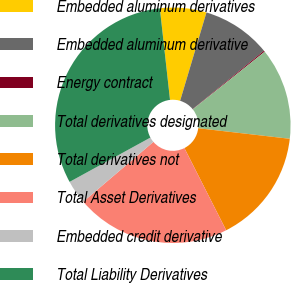Convert chart to OTSL. <chart><loc_0><loc_0><loc_500><loc_500><pie_chart><fcel>Embedded aluminum derivatives<fcel>Embedded aluminum derivative<fcel>Energy contract<fcel>Total derivatives designated<fcel>Total derivatives not<fcel>Total Asset Derivatives<fcel>Embedded credit derivative<fcel>Total Liability Derivatives<nl><fcel>6.37%<fcel>9.48%<fcel>0.16%<fcel>12.58%<fcel>15.69%<fcel>21.24%<fcel>3.26%<fcel>31.22%<nl></chart> 